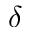Convert formula to latex. <formula><loc_0><loc_0><loc_500><loc_500>\delta</formula> 